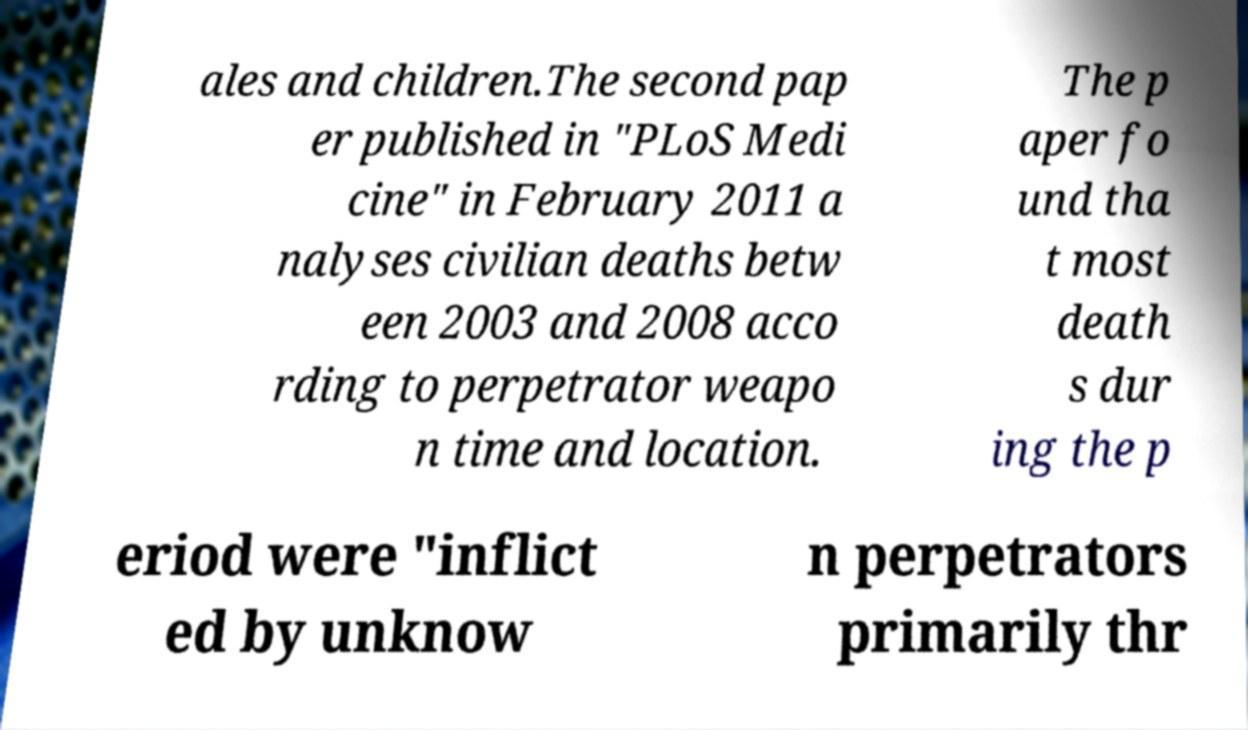What messages or text are displayed in this image? I need them in a readable, typed format. ales and children.The second pap er published in "PLoS Medi cine" in February 2011 a nalyses civilian deaths betw een 2003 and 2008 acco rding to perpetrator weapo n time and location. The p aper fo und tha t most death s dur ing the p eriod were "inflict ed by unknow n perpetrators primarily thr 